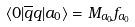<formula> <loc_0><loc_0><loc_500><loc_500>\langle 0 | \overline { q } q | a _ { 0 } \rangle = M _ { a _ { 0 } } f _ { a _ { 0 } }</formula> 